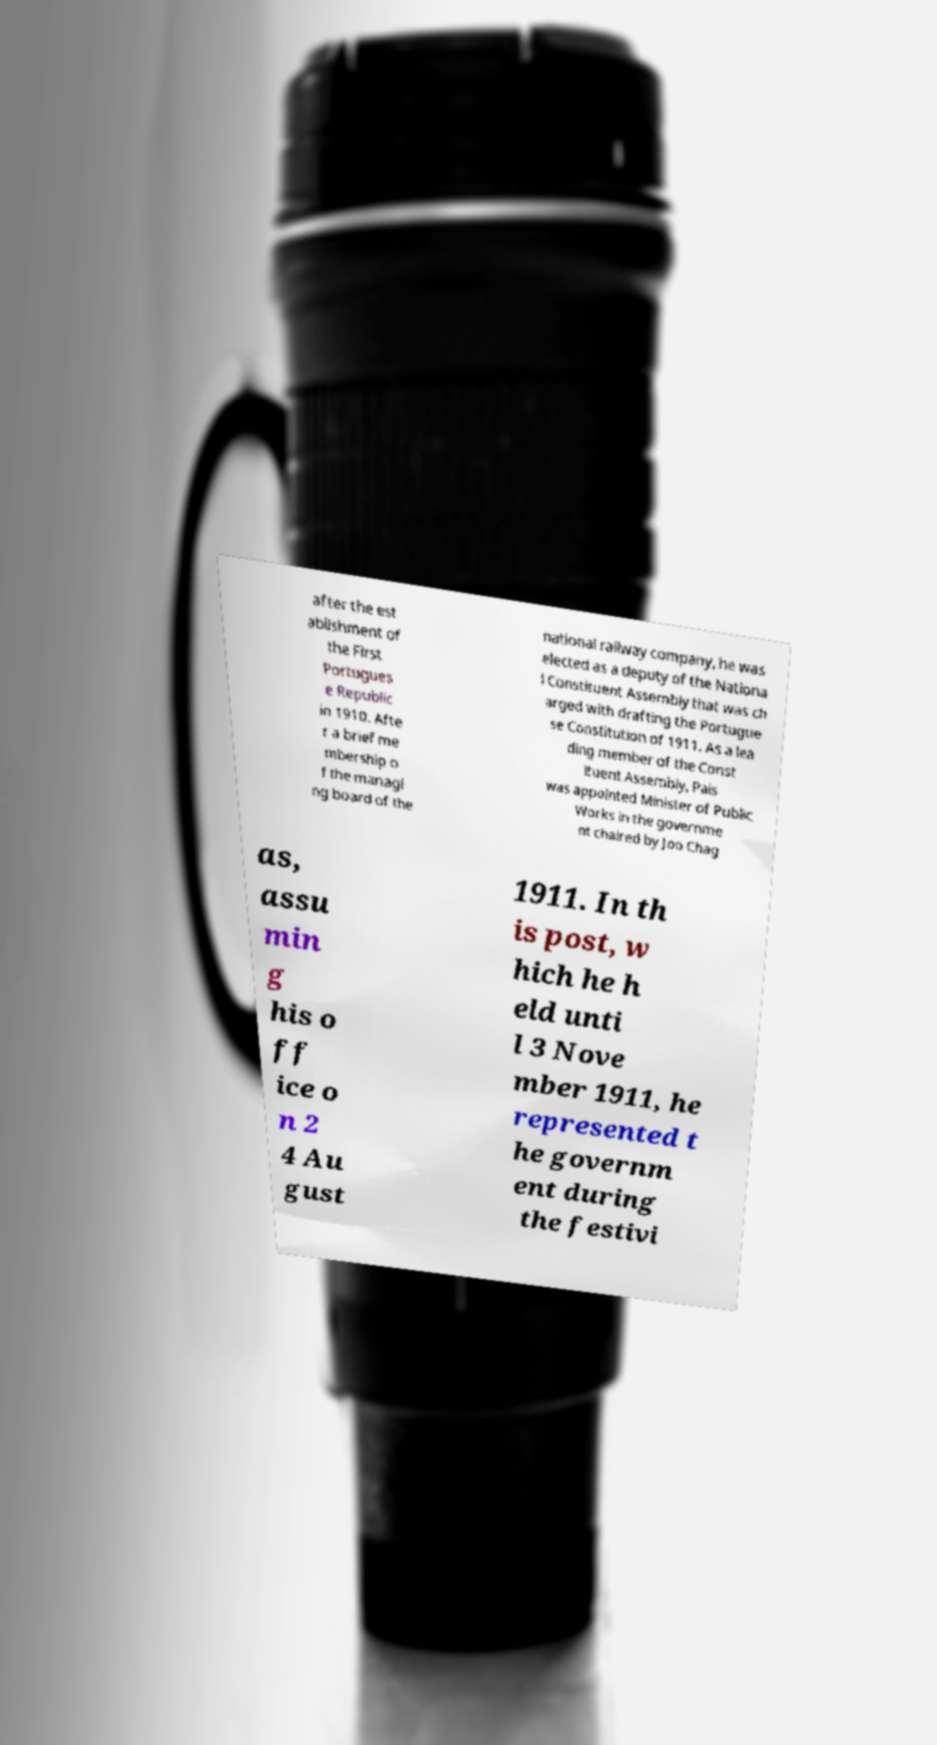What messages or text are displayed in this image? I need them in a readable, typed format. after the est ablishment of the First Portugues e Republic in 1910. Afte r a brief me mbership o f the managi ng board of the national railway company, he was elected as a deputy of the Nationa l Constituent Assembly that was ch arged with drafting the Portugue se Constitution of 1911. As a lea ding member of the Const ituent Assembly, Pais was appointed Minister of Public Works in the governme nt chaired by Joo Chag as, assu min g his o ff ice o n 2 4 Au gust 1911. In th is post, w hich he h eld unti l 3 Nove mber 1911, he represented t he governm ent during the festivi 